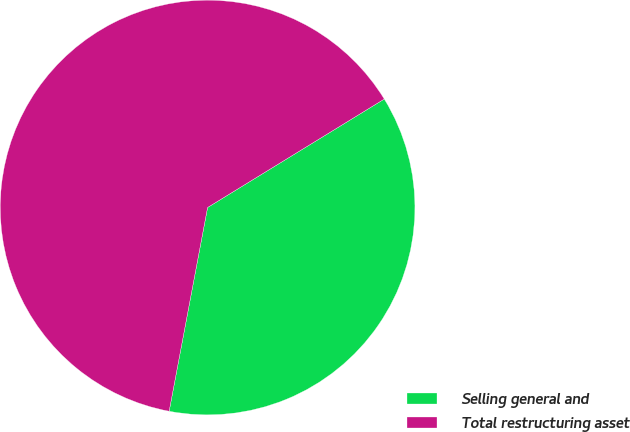<chart> <loc_0><loc_0><loc_500><loc_500><pie_chart><fcel>Selling general and<fcel>Total restructuring asset<nl><fcel>36.73%<fcel>63.27%<nl></chart> 